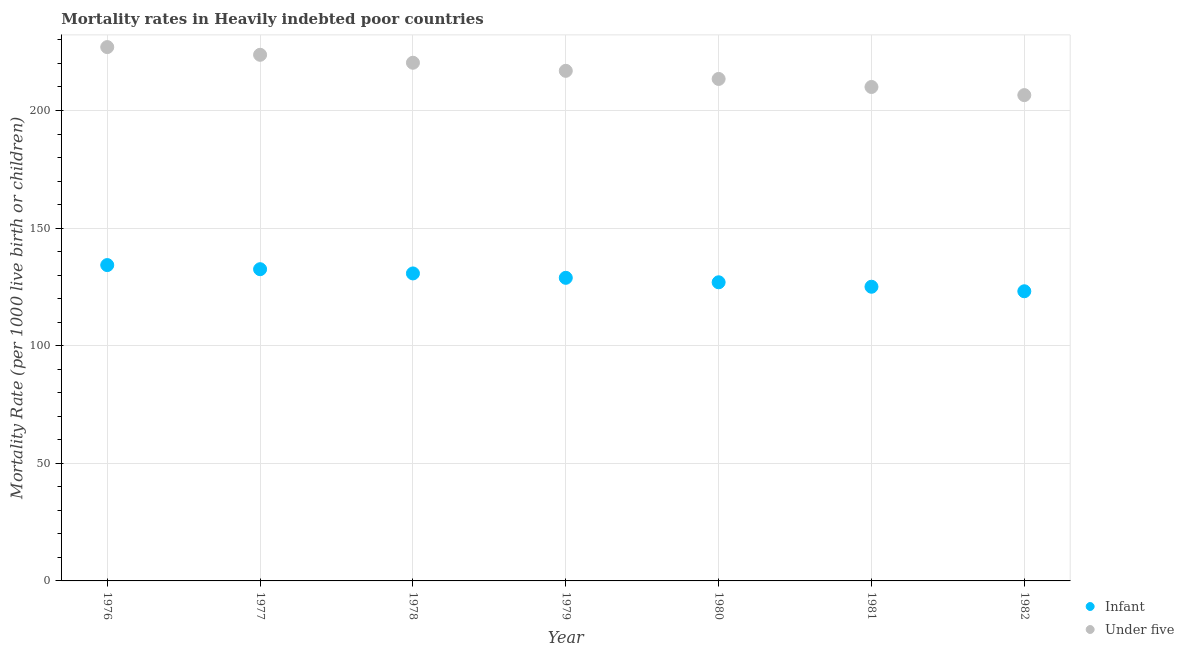How many different coloured dotlines are there?
Your response must be concise. 2. Is the number of dotlines equal to the number of legend labels?
Provide a short and direct response. Yes. What is the infant mortality rate in 1977?
Make the answer very short. 132.53. Across all years, what is the maximum under-5 mortality rate?
Make the answer very short. 226.97. Across all years, what is the minimum infant mortality rate?
Your answer should be compact. 123.15. In which year was the under-5 mortality rate maximum?
Keep it short and to the point. 1976. In which year was the infant mortality rate minimum?
Offer a very short reply. 1982. What is the total infant mortality rate in the graph?
Give a very brief answer. 901.62. What is the difference between the under-5 mortality rate in 1978 and that in 1982?
Your response must be concise. 13.76. What is the difference between the infant mortality rate in 1978 and the under-5 mortality rate in 1977?
Keep it short and to the point. -92.96. What is the average under-5 mortality rate per year?
Provide a short and direct response. 216.83. In the year 1977, what is the difference between the under-5 mortality rate and infant mortality rate?
Your response must be concise. 91.15. In how many years, is the infant mortality rate greater than 150?
Ensure brevity in your answer.  0. What is the ratio of the under-5 mortality rate in 1977 to that in 1981?
Offer a terse response. 1.07. What is the difference between the highest and the second highest infant mortality rate?
Offer a very short reply. 1.75. What is the difference between the highest and the lowest infant mortality rate?
Your answer should be compact. 11.13. In how many years, is the under-5 mortality rate greater than the average under-5 mortality rate taken over all years?
Your answer should be very brief. 4. Is the infant mortality rate strictly greater than the under-5 mortality rate over the years?
Ensure brevity in your answer.  No. Is the under-5 mortality rate strictly less than the infant mortality rate over the years?
Your answer should be very brief. No. What is the difference between two consecutive major ticks on the Y-axis?
Give a very brief answer. 50. Are the values on the major ticks of Y-axis written in scientific E-notation?
Your answer should be very brief. No. Does the graph contain grids?
Your answer should be compact. Yes. How many legend labels are there?
Provide a succinct answer. 2. How are the legend labels stacked?
Ensure brevity in your answer.  Vertical. What is the title of the graph?
Offer a terse response. Mortality rates in Heavily indebted poor countries. Does "By country of asylum" appear as one of the legend labels in the graph?
Keep it short and to the point. No. What is the label or title of the X-axis?
Give a very brief answer. Year. What is the label or title of the Y-axis?
Offer a very short reply. Mortality Rate (per 1000 live birth or children). What is the Mortality Rate (per 1000 live birth or children) in Infant in 1976?
Provide a short and direct response. 134.29. What is the Mortality Rate (per 1000 live birth or children) in Under five in 1976?
Keep it short and to the point. 226.97. What is the Mortality Rate (per 1000 live birth or children) in Infant in 1977?
Keep it short and to the point. 132.53. What is the Mortality Rate (per 1000 live birth or children) in Under five in 1977?
Your response must be concise. 223.69. What is the Mortality Rate (per 1000 live birth or children) in Infant in 1978?
Offer a very short reply. 130.73. What is the Mortality Rate (per 1000 live birth or children) of Under five in 1978?
Provide a short and direct response. 220.31. What is the Mortality Rate (per 1000 live birth or children) of Infant in 1979?
Your answer should be very brief. 128.87. What is the Mortality Rate (per 1000 live birth or children) of Under five in 1979?
Give a very brief answer. 216.87. What is the Mortality Rate (per 1000 live birth or children) in Infant in 1980?
Give a very brief answer. 126.97. What is the Mortality Rate (per 1000 live birth or children) of Under five in 1980?
Make the answer very short. 213.42. What is the Mortality Rate (per 1000 live birth or children) in Infant in 1981?
Your answer should be very brief. 125.07. What is the Mortality Rate (per 1000 live birth or children) in Under five in 1981?
Keep it short and to the point. 210.01. What is the Mortality Rate (per 1000 live birth or children) in Infant in 1982?
Provide a short and direct response. 123.15. What is the Mortality Rate (per 1000 live birth or children) in Under five in 1982?
Ensure brevity in your answer.  206.55. Across all years, what is the maximum Mortality Rate (per 1000 live birth or children) of Infant?
Make the answer very short. 134.29. Across all years, what is the maximum Mortality Rate (per 1000 live birth or children) of Under five?
Ensure brevity in your answer.  226.97. Across all years, what is the minimum Mortality Rate (per 1000 live birth or children) of Infant?
Provide a succinct answer. 123.15. Across all years, what is the minimum Mortality Rate (per 1000 live birth or children) in Under five?
Your response must be concise. 206.55. What is the total Mortality Rate (per 1000 live birth or children) in Infant in the graph?
Keep it short and to the point. 901.62. What is the total Mortality Rate (per 1000 live birth or children) in Under five in the graph?
Make the answer very short. 1517.82. What is the difference between the Mortality Rate (per 1000 live birth or children) of Infant in 1976 and that in 1977?
Provide a succinct answer. 1.75. What is the difference between the Mortality Rate (per 1000 live birth or children) of Under five in 1976 and that in 1977?
Provide a succinct answer. 3.28. What is the difference between the Mortality Rate (per 1000 live birth or children) in Infant in 1976 and that in 1978?
Offer a very short reply. 3.55. What is the difference between the Mortality Rate (per 1000 live birth or children) of Under five in 1976 and that in 1978?
Ensure brevity in your answer.  6.66. What is the difference between the Mortality Rate (per 1000 live birth or children) in Infant in 1976 and that in 1979?
Keep it short and to the point. 5.42. What is the difference between the Mortality Rate (per 1000 live birth or children) of Under five in 1976 and that in 1979?
Provide a succinct answer. 10.1. What is the difference between the Mortality Rate (per 1000 live birth or children) of Infant in 1976 and that in 1980?
Make the answer very short. 7.32. What is the difference between the Mortality Rate (per 1000 live birth or children) of Under five in 1976 and that in 1980?
Give a very brief answer. 13.55. What is the difference between the Mortality Rate (per 1000 live birth or children) of Infant in 1976 and that in 1981?
Ensure brevity in your answer.  9.21. What is the difference between the Mortality Rate (per 1000 live birth or children) in Under five in 1976 and that in 1981?
Your answer should be compact. 16.96. What is the difference between the Mortality Rate (per 1000 live birth or children) of Infant in 1976 and that in 1982?
Give a very brief answer. 11.13. What is the difference between the Mortality Rate (per 1000 live birth or children) in Under five in 1976 and that in 1982?
Your answer should be compact. 20.42. What is the difference between the Mortality Rate (per 1000 live birth or children) of Infant in 1977 and that in 1978?
Your answer should be very brief. 1.8. What is the difference between the Mortality Rate (per 1000 live birth or children) in Under five in 1977 and that in 1978?
Your answer should be compact. 3.38. What is the difference between the Mortality Rate (per 1000 live birth or children) of Infant in 1977 and that in 1979?
Provide a succinct answer. 3.67. What is the difference between the Mortality Rate (per 1000 live birth or children) of Under five in 1977 and that in 1979?
Give a very brief answer. 6.82. What is the difference between the Mortality Rate (per 1000 live birth or children) of Infant in 1977 and that in 1980?
Ensure brevity in your answer.  5.56. What is the difference between the Mortality Rate (per 1000 live birth or children) in Under five in 1977 and that in 1980?
Your response must be concise. 10.27. What is the difference between the Mortality Rate (per 1000 live birth or children) in Infant in 1977 and that in 1981?
Your answer should be compact. 7.46. What is the difference between the Mortality Rate (per 1000 live birth or children) of Under five in 1977 and that in 1981?
Offer a terse response. 13.68. What is the difference between the Mortality Rate (per 1000 live birth or children) of Infant in 1977 and that in 1982?
Keep it short and to the point. 9.38. What is the difference between the Mortality Rate (per 1000 live birth or children) in Under five in 1977 and that in 1982?
Your answer should be compact. 17.14. What is the difference between the Mortality Rate (per 1000 live birth or children) in Infant in 1978 and that in 1979?
Provide a short and direct response. 1.87. What is the difference between the Mortality Rate (per 1000 live birth or children) in Under five in 1978 and that in 1979?
Provide a succinct answer. 3.43. What is the difference between the Mortality Rate (per 1000 live birth or children) in Infant in 1978 and that in 1980?
Offer a very short reply. 3.76. What is the difference between the Mortality Rate (per 1000 live birth or children) in Under five in 1978 and that in 1980?
Offer a very short reply. 6.89. What is the difference between the Mortality Rate (per 1000 live birth or children) of Infant in 1978 and that in 1981?
Make the answer very short. 5.66. What is the difference between the Mortality Rate (per 1000 live birth or children) in Under five in 1978 and that in 1981?
Ensure brevity in your answer.  10.3. What is the difference between the Mortality Rate (per 1000 live birth or children) of Infant in 1978 and that in 1982?
Provide a short and direct response. 7.58. What is the difference between the Mortality Rate (per 1000 live birth or children) in Under five in 1978 and that in 1982?
Give a very brief answer. 13.76. What is the difference between the Mortality Rate (per 1000 live birth or children) in Infant in 1979 and that in 1980?
Your response must be concise. 1.9. What is the difference between the Mortality Rate (per 1000 live birth or children) in Under five in 1979 and that in 1980?
Offer a very short reply. 3.45. What is the difference between the Mortality Rate (per 1000 live birth or children) of Infant in 1979 and that in 1981?
Your response must be concise. 3.79. What is the difference between the Mortality Rate (per 1000 live birth or children) in Under five in 1979 and that in 1981?
Provide a short and direct response. 6.87. What is the difference between the Mortality Rate (per 1000 live birth or children) of Infant in 1979 and that in 1982?
Provide a succinct answer. 5.72. What is the difference between the Mortality Rate (per 1000 live birth or children) of Under five in 1979 and that in 1982?
Offer a very short reply. 10.32. What is the difference between the Mortality Rate (per 1000 live birth or children) in Infant in 1980 and that in 1981?
Your answer should be very brief. 1.9. What is the difference between the Mortality Rate (per 1000 live birth or children) of Under five in 1980 and that in 1981?
Your response must be concise. 3.42. What is the difference between the Mortality Rate (per 1000 live birth or children) of Infant in 1980 and that in 1982?
Provide a short and direct response. 3.82. What is the difference between the Mortality Rate (per 1000 live birth or children) in Under five in 1980 and that in 1982?
Your answer should be very brief. 6.87. What is the difference between the Mortality Rate (per 1000 live birth or children) of Infant in 1981 and that in 1982?
Your answer should be compact. 1.92. What is the difference between the Mortality Rate (per 1000 live birth or children) of Under five in 1981 and that in 1982?
Make the answer very short. 3.46. What is the difference between the Mortality Rate (per 1000 live birth or children) of Infant in 1976 and the Mortality Rate (per 1000 live birth or children) of Under five in 1977?
Give a very brief answer. -89.4. What is the difference between the Mortality Rate (per 1000 live birth or children) in Infant in 1976 and the Mortality Rate (per 1000 live birth or children) in Under five in 1978?
Your answer should be very brief. -86.02. What is the difference between the Mortality Rate (per 1000 live birth or children) of Infant in 1976 and the Mortality Rate (per 1000 live birth or children) of Under five in 1979?
Ensure brevity in your answer.  -82.59. What is the difference between the Mortality Rate (per 1000 live birth or children) of Infant in 1976 and the Mortality Rate (per 1000 live birth or children) of Under five in 1980?
Offer a very short reply. -79.14. What is the difference between the Mortality Rate (per 1000 live birth or children) of Infant in 1976 and the Mortality Rate (per 1000 live birth or children) of Under five in 1981?
Offer a terse response. -75.72. What is the difference between the Mortality Rate (per 1000 live birth or children) of Infant in 1976 and the Mortality Rate (per 1000 live birth or children) of Under five in 1982?
Keep it short and to the point. -72.26. What is the difference between the Mortality Rate (per 1000 live birth or children) in Infant in 1977 and the Mortality Rate (per 1000 live birth or children) in Under five in 1978?
Provide a short and direct response. -87.77. What is the difference between the Mortality Rate (per 1000 live birth or children) of Infant in 1977 and the Mortality Rate (per 1000 live birth or children) of Under five in 1979?
Your response must be concise. -84.34. What is the difference between the Mortality Rate (per 1000 live birth or children) of Infant in 1977 and the Mortality Rate (per 1000 live birth or children) of Under five in 1980?
Your response must be concise. -80.89. What is the difference between the Mortality Rate (per 1000 live birth or children) in Infant in 1977 and the Mortality Rate (per 1000 live birth or children) in Under five in 1981?
Offer a very short reply. -77.47. What is the difference between the Mortality Rate (per 1000 live birth or children) in Infant in 1977 and the Mortality Rate (per 1000 live birth or children) in Under five in 1982?
Your answer should be compact. -74.01. What is the difference between the Mortality Rate (per 1000 live birth or children) of Infant in 1978 and the Mortality Rate (per 1000 live birth or children) of Under five in 1979?
Your response must be concise. -86.14. What is the difference between the Mortality Rate (per 1000 live birth or children) of Infant in 1978 and the Mortality Rate (per 1000 live birth or children) of Under five in 1980?
Offer a very short reply. -82.69. What is the difference between the Mortality Rate (per 1000 live birth or children) of Infant in 1978 and the Mortality Rate (per 1000 live birth or children) of Under five in 1981?
Your response must be concise. -79.27. What is the difference between the Mortality Rate (per 1000 live birth or children) in Infant in 1978 and the Mortality Rate (per 1000 live birth or children) in Under five in 1982?
Ensure brevity in your answer.  -75.81. What is the difference between the Mortality Rate (per 1000 live birth or children) in Infant in 1979 and the Mortality Rate (per 1000 live birth or children) in Under five in 1980?
Give a very brief answer. -84.55. What is the difference between the Mortality Rate (per 1000 live birth or children) in Infant in 1979 and the Mortality Rate (per 1000 live birth or children) in Under five in 1981?
Your answer should be very brief. -81.14. What is the difference between the Mortality Rate (per 1000 live birth or children) of Infant in 1979 and the Mortality Rate (per 1000 live birth or children) of Under five in 1982?
Ensure brevity in your answer.  -77.68. What is the difference between the Mortality Rate (per 1000 live birth or children) of Infant in 1980 and the Mortality Rate (per 1000 live birth or children) of Under five in 1981?
Your answer should be very brief. -83.04. What is the difference between the Mortality Rate (per 1000 live birth or children) of Infant in 1980 and the Mortality Rate (per 1000 live birth or children) of Under five in 1982?
Ensure brevity in your answer.  -79.58. What is the difference between the Mortality Rate (per 1000 live birth or children) in Infant in 1981 and the Mortality Rate (per 1000 live birth or children) in Under five in 1982?
Offer a very short reply. -81.47. What is the average Mortality Rate (per 1000 live birth or children) in Infant per year?
Provide a short and direct response. 128.8. What is the average Mortality Rate (per 1000 live birth or children) in Under five per year?
Give a very brief answer. 216.83. In the year 1976, what is the difference between the Mortality Rate (per 1000 live birth or children) of Infant and Mortality Rate (per 1000 live birth or children) of Under five?
Make the answer very short. -92.68. In the year 1977, what is the difference between the Mortality Rate (per 1000 live birth or children) in Infant and Mortality Rate (per 1000 live birth or children) in Under five?
Provide a short and direct response. -91.15. In the year 1978, what is the difference between the Mortality Rate (per 1000 live birth or children) in Infant and Mortality Rate (per 1000 live birth or children) in Under five?
Offer a terse response. -89.57. In the year 1979, what is the difference between the Mortality Rate (per 1000 live birth or children) in Infant and Mortality Rate (per 1000 live birth or children) in Under five?
Ensure brevity in your answer.  -88. In the year 1980, what is the difference between the Mortality Rate (per 1000 live birth or children) of Infant and Mortality Rate (per 1000 live birth or children) of Under five?
Provide a short and direct response. -86.45. In the year 1981, what is the difference between the Mortality Rate (per 1000 live birth or children) of Infant and Mortality Rate (per 1000 live birth or children) of Under five?
Ensure brevity in your answer.  -84.93. In the year 1982, what is the difference between the Mortality Rate (per 1000 live birth or children) in Infant and Mortality Rate (per 1000 live birth or children) in Under five?
Offer a terse response. -83.4. What is the ratio of the Mortality Rate (per 1000 live birth or children) of Infant in 1976 to that in 1977?
Keep it short and to the point. 1.01. What is the ratio of the Mortality Rate (per 1000 live birth or children) of Under five in 1976 to that in 1977?
Ensure brevity in your answer.  1.01. What is the ratio of the Mortality Rate (per 1000 live birth or children) in Infant in 1976 to that in 1978?
Keep it short and to the point. 1.03. What is the ratio of the Mortality Rate (per 1000 live birth or children) of Under five in 1976 to that in 1978?
Give a very brief answer. 1.03. What is the ratio of the Mortality Rate (per 1000 live birth or children) in Infant in 1976 to that in 1979?
Offer a terse response. 1.04. What is the ratio of the Mortality Rate (per 1000 live birth or children) in Under five in 1976 to that in 1979?
Make the answer very short. 1.05. What is the ratio of the Mortality Rate (per 1000 live birth or children) in Infant in 1976 to that in 1980?
Your answer should be compact. 1.06. What is the ratio of the Mortality Rate (per 1000 live birth or children) in Under five in 1976 to that in 1980?
Ensure brevity in your answer.  1.06. What is the ratio of the Mortality Rate (per 1000 live birth or children) of Infant in 1976 to that in 1981?
Provide a succinct answer. 1.07. What is the ratio of the Mortality Rate (per 1000 live birth or children) in Under five in 1976 to that in 1981?
Provide a short and direct response. 1.08. What is the ratio of the Mortality Rate (per 1000 live birth or children) of Infant in 1976 to that in 1982?
Ensure brevity in your answer.  1.09. What is the ratio of the Mortality Rate (per 1000 live birth or children) of Under five in 1976 to that in 1982?
Your answer should be compact. 1.1. What is the ratio of the Mortality Rate (per 1000 live birth or children) of Infant in 1977 to that in 1978?
Your answer should be very brief. 1.01. What is the ratio of the Mortality Rate (per 1000 live birth or children) in Under five in 1977 to that in 1978?
Offer a very short reply. 1.02. What is the ratio of the Mortality Rate (per 1000 live birth or children) in Infant in 1977 to that in 1979?
Make the answer very short. 1.03. What is the ratio of the Mortality Rate (per 1000 live birth or children) in Under five in 1977 to that in 1979?
Your response must be concise. 1.03. What is the ratio of the Mortality Rate (per 1000 live birth or children) in Infant in 1977 to that in 1980?
Make the answer very short. 1.04. What is the ratio of the Mortality Rate (per 1000 live birth or children) of Under five in 1977 to that in 1980?
Offer a terse response. 1.05. What is the ratio of the Mortality Rate (per 1000 live birth or children) in Infant in 1977 to that in 1981?
Your answer should be compact. 1.06. What is the ratio of the Mortality Rate (per 1000 live birth or children) of Under five in 1977 to that in 1981?
Your answer should be compact. 1.07. What is the ratio of the Mortality Rate (per 1000 live birth or children) of Infant in 1977 to that in 1982?
Give a very brief answer. 1.08. What is the ratio of the Mortality Rate (per 1000 live birth or children) in Under five in 1977 to that in 1982?
Your answer should be very brief. 1.08. What is the ratio of the Mortality Rate (per 1000 live birth or children) in Infant in 1978 to that in 1979?
Your response must be concise. 1.01. What is the ratio of the Mortality Rate (per 1000 live birth or children) of Under five in 1978 to that in 1979?
Ensure brevity in your answer.  1.02. What is the ratio of the Mortality Rate (per 1000 live birth or children) in Infant in 1978 to that in 1980?
Your response must be concise. 1.03. What is the ratio of the Mortality Rate (per 1000 live birth or children) of Under five in 1978 to that in 1980?
Your answer should be compact. 1.03. What is the ratio of the Mortality Rate (per 1000 live birth or children) of Infant in 1978 to that in 1981?
Your response must be concise. 1.05. What is the ratio of the Mortality Rate (per 1000 live birth or children) in Under five in 1978 to that in 1981?
Provide a short and direct response. 1.05. What is the ratio of the Mortality Rate (per 1000 live birth or children) in Infant in 1978 to that in 1982?
Offer a very short reply. 1.06. What is the ratio of the Mortality Rate (per 1000 live birth or children) in Under five in 1978 to that in 1982?
Give a very brief answer. 1.07. What is the ratio of the Mortality Rate (per 1000 live birth or children) of Infant in 1979 to that in 1980?
Offer a terse response. 1.01. What is the ratio of the Mortality Rate (per 1000 live birth or children) of Under five in 1979 to that in 1980?
Provide a succinct answer. 1.02. What is the ratio of the Mortality Rate (per 1000 live birth or children) of Infant in 1979 to that in 1981?
Make the answer very short. 1.03. What is the ratio of the Mortality Rate (per 1000 live birth or children) of Under five in 1979 to that in 1981?
Provide a short and direct response. 1.03. What is the ratio of the Mortality Rate (per 1000 live birth or children) in Infant in 1979 to that in 1982?
Offer a very short reply. 1.05. What is the ratio of the Mortality Rate (per 1000 live birth or children) of Infant in 1980 to that in 1981?
Provide a short and direct response. 1.02. What is the ratio of the Mortality Rate (per 1000 live birth or children) of Under five in 1980 to that in 1981?
Keep it short and to the point. 1.02. What is the ratio of the Mortality Rate (per 1000 live birth or children) in Infant in 1980 to that in 1982?
Provide a short and direct response. 1.03. What is the ratio of the Mortality Rate (per 1000 live birth or children) of Under five in 1980 to that in 1982?
Keep it short and to the point. 1.03. What is the ratio of the Mortality Rate (per 1000 live birth or children) of Infant in 1981 to that in 1982?
Provide a succinct answer. 1.02. What is the ratio of the Mortality Rate (per 1000 live birth or children) of Under five in 1981 to that in 1982?
Your response must be concise. 1.02. What is the difference between the highest and the second highest Mortality Rate (per 1000 live birth or children) of Infant?
Your answer should be very brief. 1.75. What is the difference between the highest and the second highest Mortality Rate (per 1000 live birth or children) of Under five?
Provide a short and direct response. 3.28. What is the difference between the highest and the lowest Mortality Rate (per 1000 live birth or children) in Infant?
Provide a succinct answer. 11.13. What is the difference between the highest and the lowest Mortality Rate (per 1000 live birth or children) of Under five?
Provide a succinct answer. 20.42. 